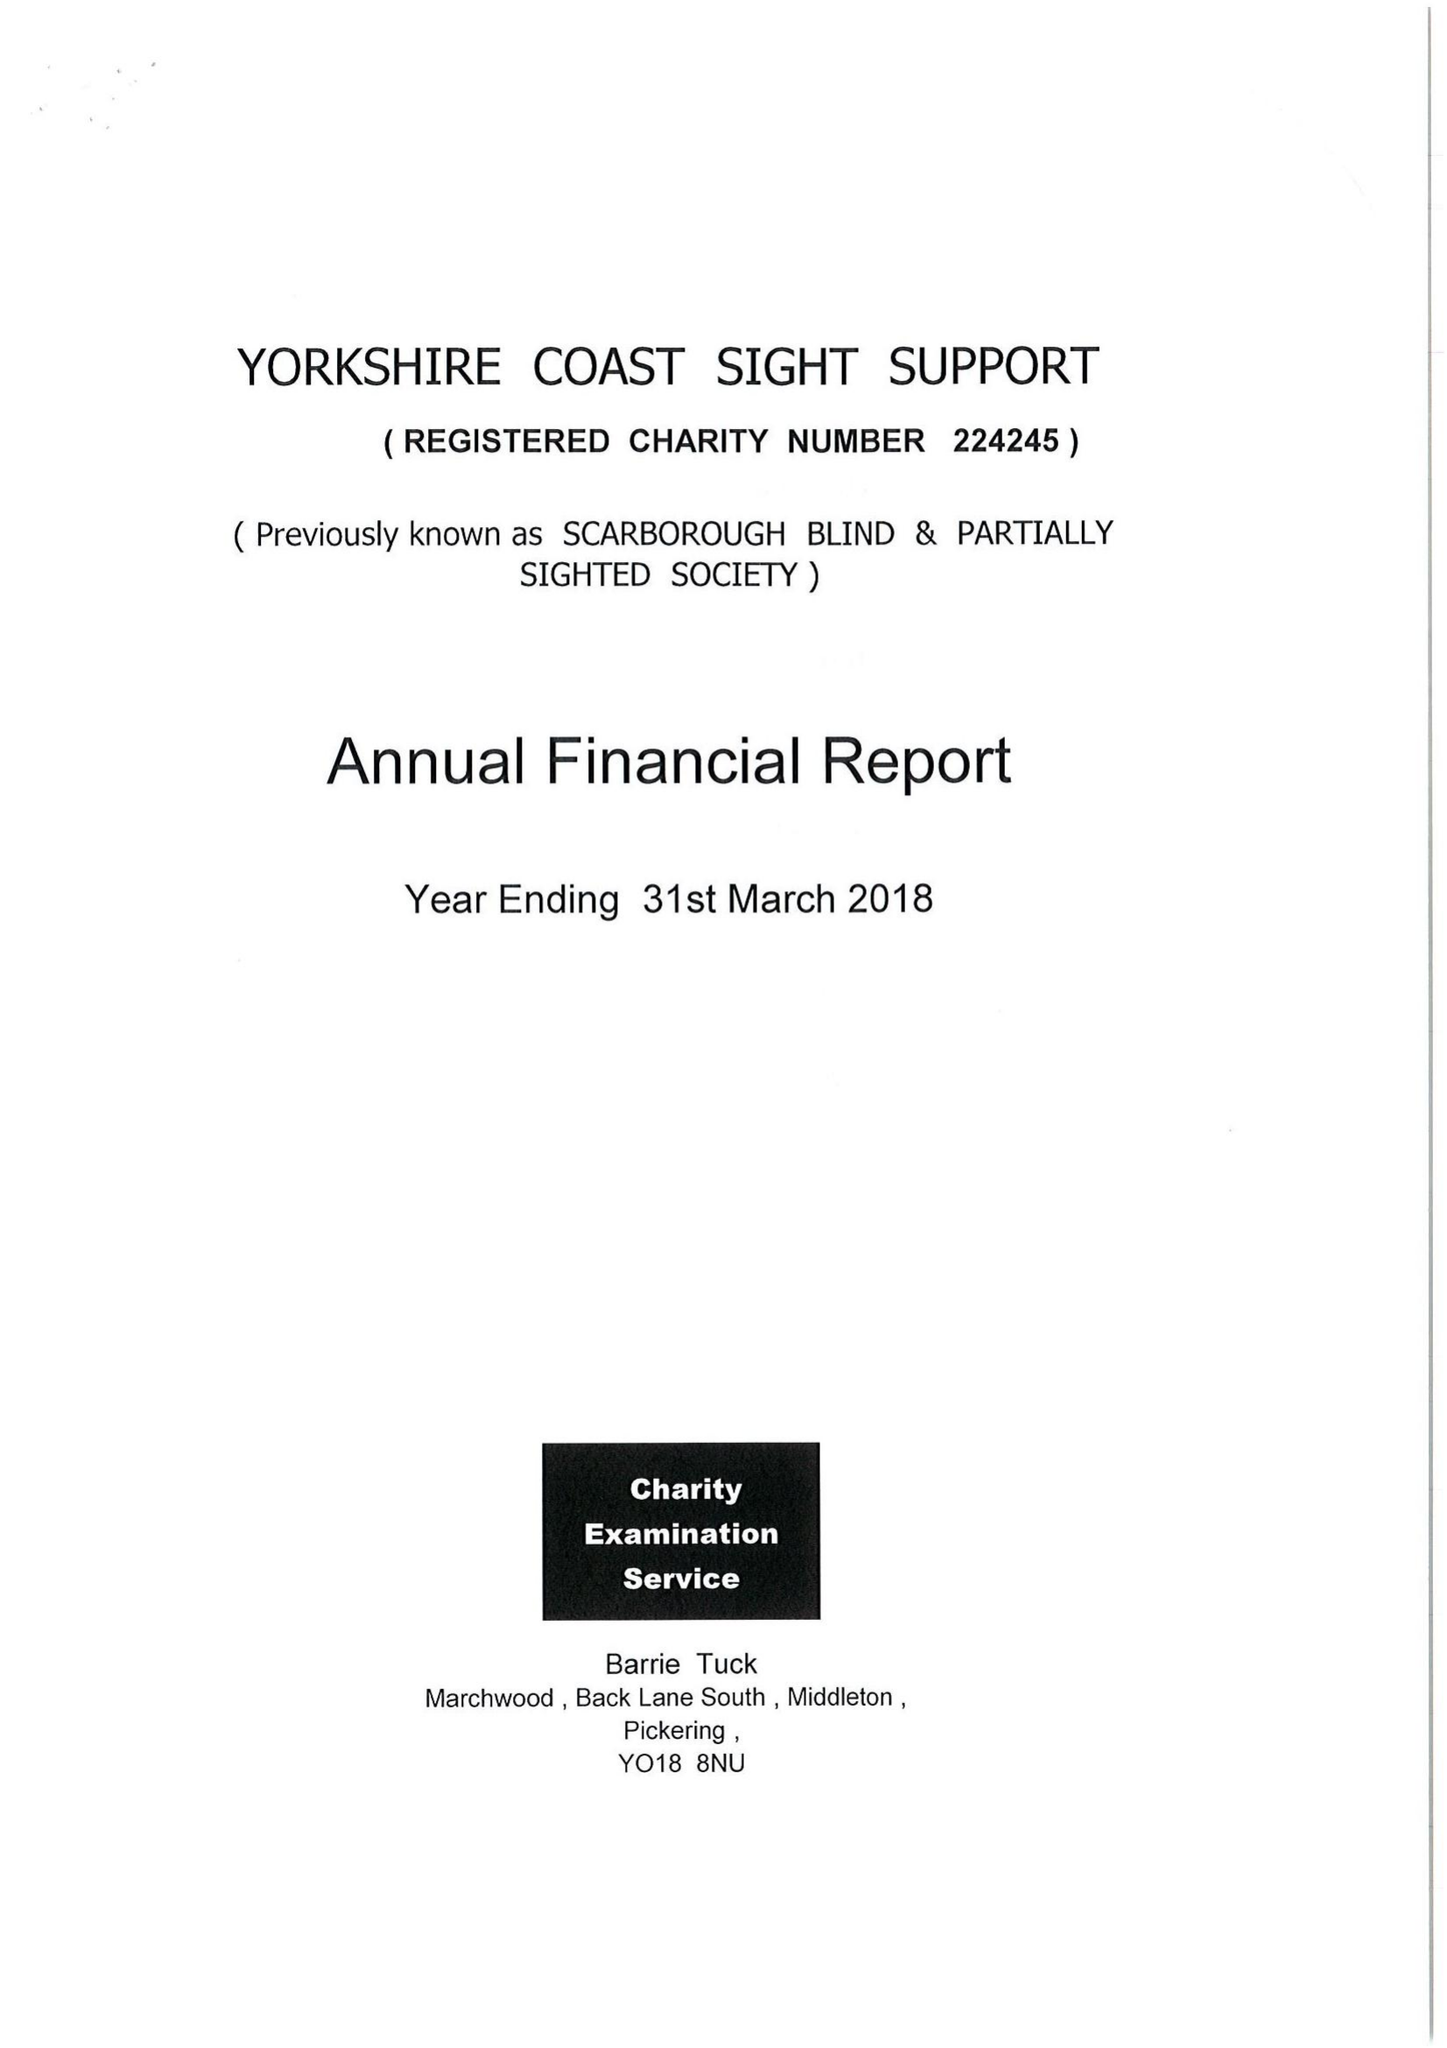What is the value for the report_date?
Answer the question using a single word or phrase. 2018-03-31 